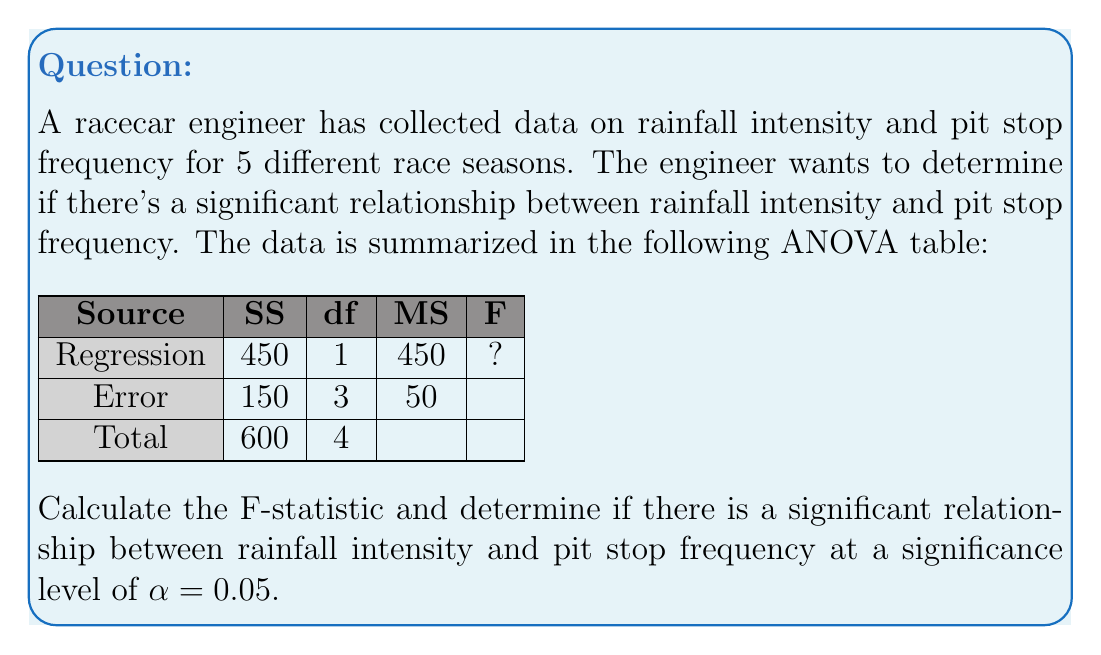What is the answer to this math problem? To solve this problem, we'll follow these steps:

1) First, we need to calculate the F-statistic using the information provided in the ANOVA table.

2) The F-statistic is calculated as:

   $$F = \frac{MS_{Regression}}{MS_{Error}}$$

   Where $MS_{Regression}$ is the Mean Square for Regression and $MS_{Error}$ is the Mean Square for Error.

3) From the ANOVA table:
   $MS_{Regression} = 450$
   $MS_{Error} = 50$

4) Plugging these values into the formula:

   $$F = \frac{450}{50} = 9$$

5) Now that we have the F-statistic, we need to compare it to the critical F-value.

6) The degrees of freedom for the numerator (df1) is 1, and for the denominator (df2) is 3.

7) For α = 0.05, df1 = 1, and df2 = 3, the critical F-value is approximately 10.13.

8) Since our calculated F-statistic (9) is less than the critical F-value (10.13), we fail to reject the null hypothesis.
Answer: F = 9; Not significant at α = 0.05 